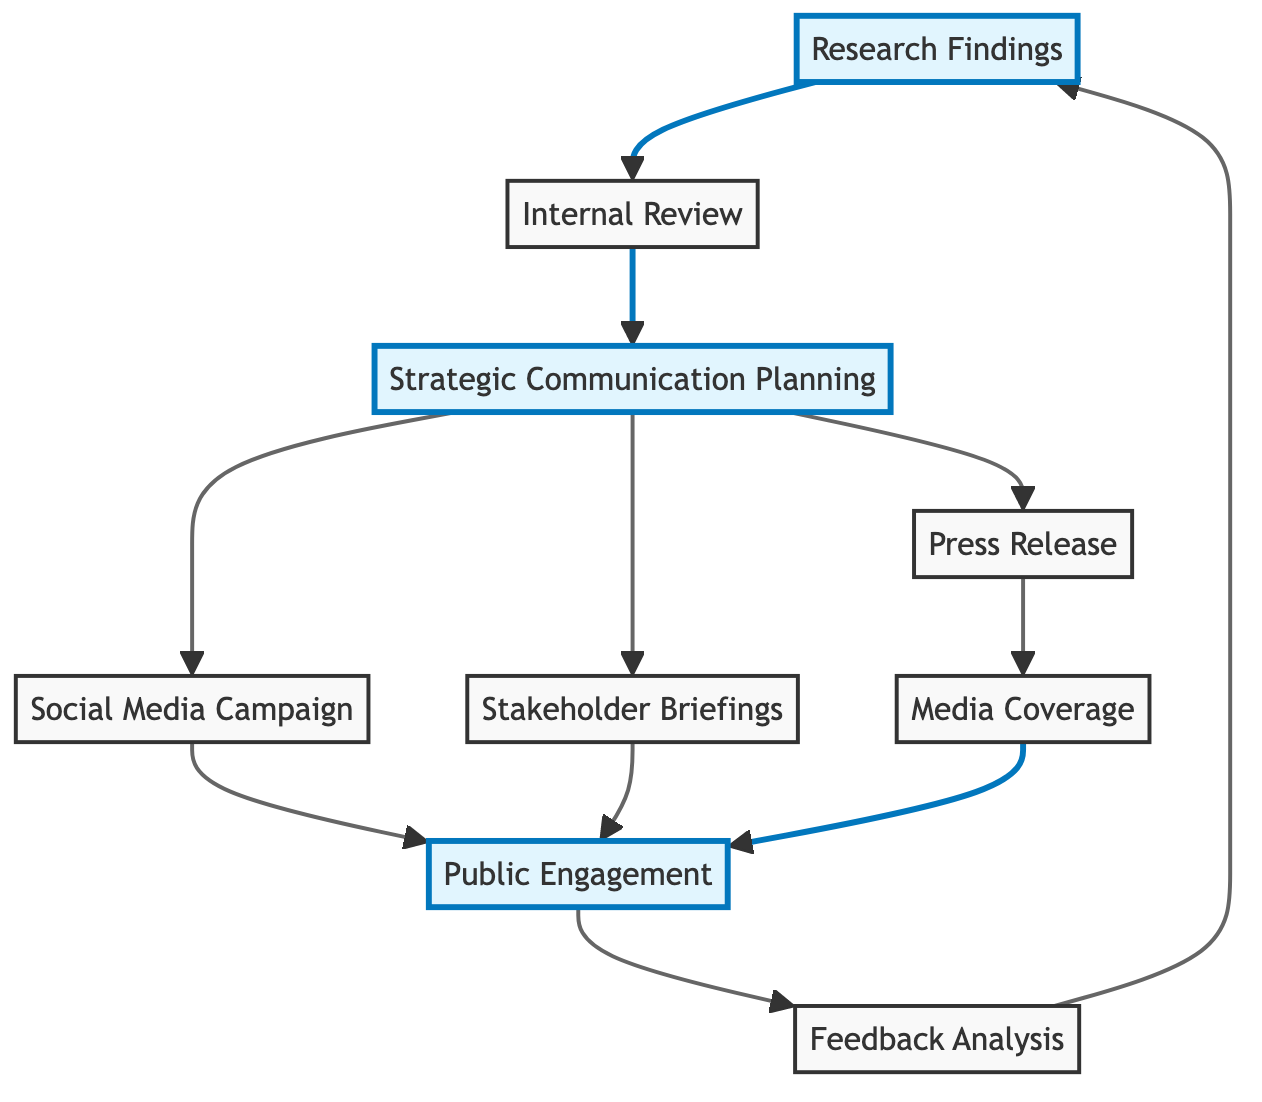What is the first step in the flow? The first step in the flow of the diagram is represented by the "Research Findings" node, which illustrates that new scientific discoveries initiate the communication strategy.
Answer: Research Findings How many nodes are present in the diagram? By counting the distinct labeled sections within the diagram, there are a total of 9 nodes that represent different stages in the communication flow.
Answer: 9 What is the node that follows "Internal Review"? The "Strategic Communication Planning" node follows "Internal Review," indicating that after the internal assessment, a plan for communication will be developed.
Answer: Strategic Communication Planning Which nodes lead to "Public Engagement"? Both "Social Media Campaign" and "Stakeholder Briefings" lead to "Public Engagement," showing that multiple strategies contribute to public interaction following their respective activities.
Answer: Social Media Campaign, Stakeholder Briefings What describes the purpose of "Feedback Analysis"? The purpose of "Feedback Analysis" is to assess public and stakeholder feedback in order to improve future communication strategies.
Answer: To assess feedback Which communication strategy is directly related to media outlets? The "Press Release" node is directly related to media outlets, as it involves the preparation and distribution of an official statement to the media.
Answer: Press Release How does the flow restart after "Feedback Analysis"? After completing "Feedback Analysis," the flow returns to "Research Findings," signifying the cyclical nature of the communication process where feedback informs future research communications.
Answer: Research Findings What is the last step in the flow? The last step in the flow of the diagram, before it loops back, is "Feedback Analysis," which indicates the continuous evaluation process.
Answer: Feedback Analysis Which node has an italicized description? The nodes "Internal Review" and "Media Coverage" both have italicized descriptions, indicating a different emphasis compared to the other nodes.
Answer: Internal Review, Media Coverage 